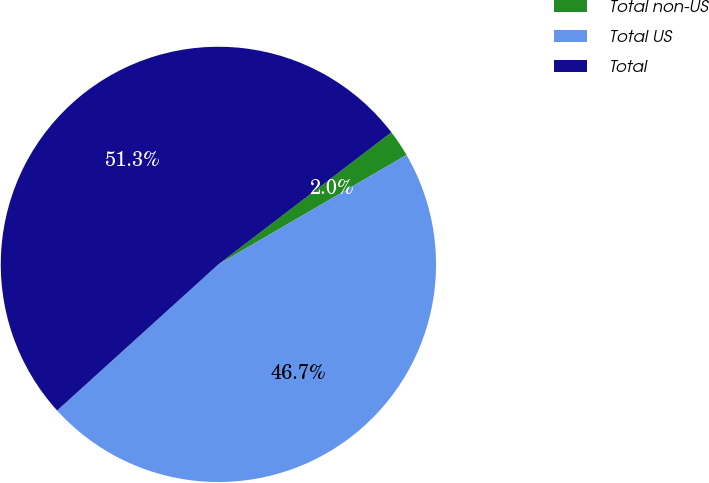Convert chart to OTSL. <chart><loc_0><loc_0><loc_500><loc_500><pie_chart><fcel>Total non-US<fcel>Total US<fcel>Total<nl><fcel>1.99%<fcel>46.67%<fcel>51.34%<nl></chart> 